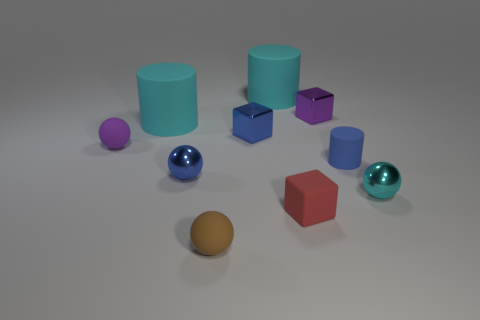There is a tiny shiny ball that is on the left side of the tiny cyan thing; is it the same color as the large matte cylinder that is right of the brown object?
Provide a succinct answer. No. Is the number of brown objects that are behind the blue matte object greater than the number of big cyan rubber things that are to the right of the purple matte ball?
Your response must be concise. No. What is the small cyan sphere made of?
Offer a terse response. Metal. What shape is the purple thing that is in front of the matte cylinder left of the small ball in front of the cyan metallic object?
Your answer should be compact. Sphere. How many other objects are there of the same material as the small red block?
Your answer should be very brief. 5. Do the cyan object that is right of the purple cube and the cyan cylinder that is in front of the purple shiny cube have the same material?
Your answer should be compact. No. What number of objects are in front of the tiny matte cylinder and behind the blue metallic cube?
Offer a very short reply. 0. Are there any green matte objects that have the same shape as the tiny brown object?
Make the answer very short. No. What shape is the blue rubber object that is the same size as the rubber cube?
Provide a short and direct response. Cylinder. Are there the same number of red blocks that are in front of the cyan metal thing and metal objects that are in front of the blue matte object?
Provide a succinct answer. No. 